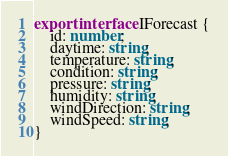<code> <loc_0><loc_0><loc_500><loc_500><_TypeScript_>export interface IForecast {
    id: number;
    daytime: string;
    temperature: string;
    condition: string;
    pressure: string;
    humidity: string;
    windDirection: string;
    windSpeed: string;
}
</code> 